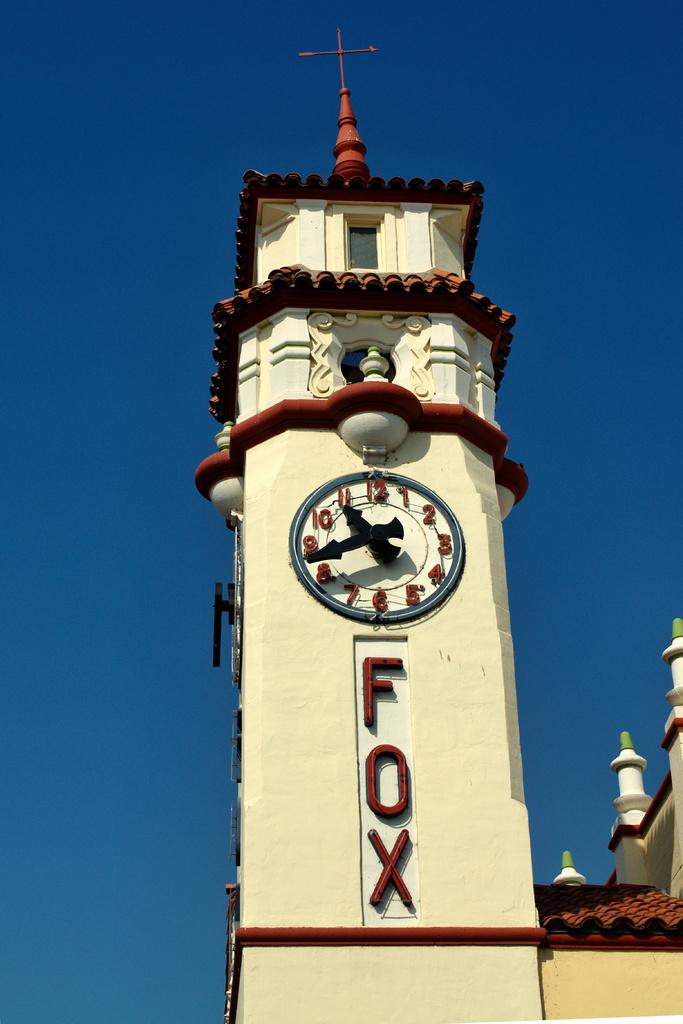What is the main structure in the image? There is a clock tower in the image. What words can be seen on a wall in the image? The words "fox" are visible on a wall in the image. What symbol is present on the top of the building? There is a cross mark on the top of the building. What part of the sky can be seen in the image? The sky is visible on the left side of the image. How many geese are on the roof of the building in the image? There are no geese present on the roof of the building in the image. What type of material is the roof made of in the image? The image does not provide information about the roof's material. 